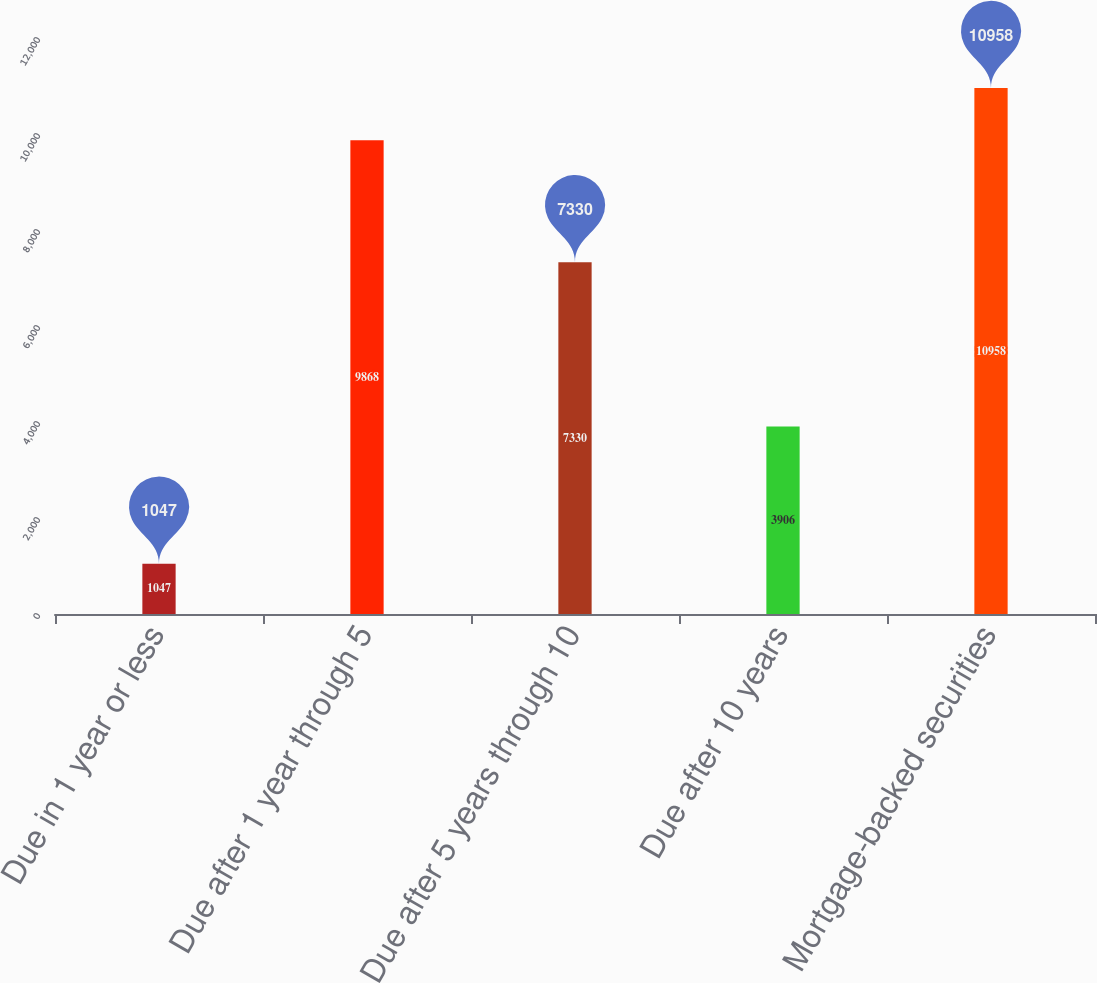<chart> <loc_0><loc_0><loc_500><loc_500><bar_chart><fcel>Due in 1 year or less<fcel>Due after 1 year through 5<fcel>Due after 5 years through 10<fcel>Due after 10 years<fcel>Mortgage-backed securities<nl><fcel>1047<fcel>9868<fcel>7330<fcel>3906<fcel>10958<nl></chart> 